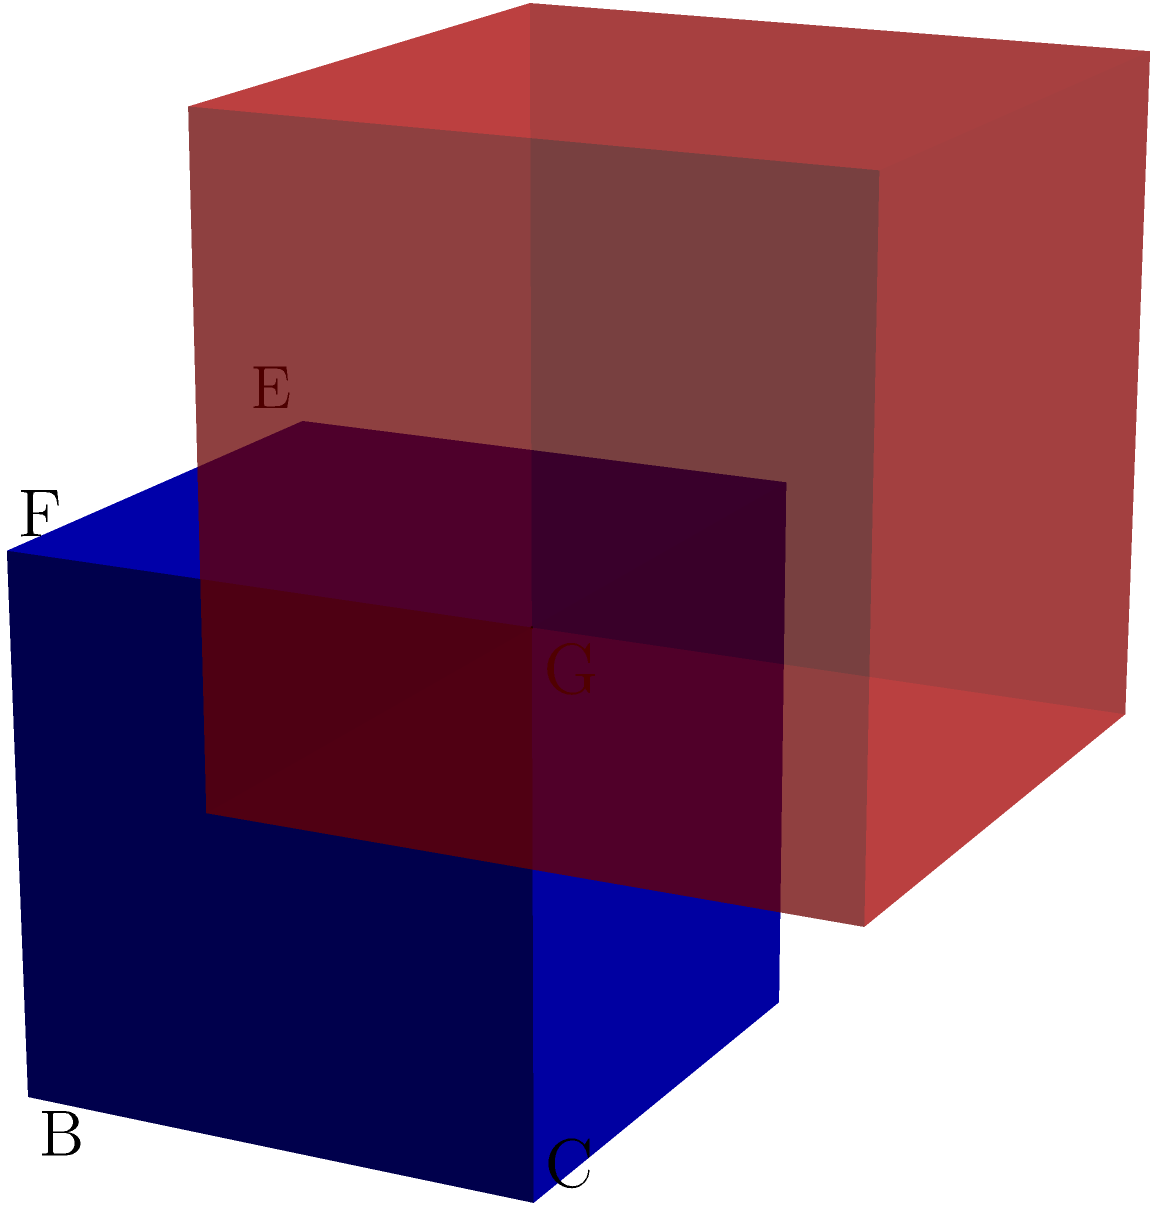In a self-defense scenario, you need to quickly assess and adapt your stance. The blue cube represents your initial position, and the red cube represents the optimal defensive stance. Which single 90-degree rotation around an edge of the blue cube will align it with the red cube, maximizing your personal safety? To solve this spatial problem, let's approach it step-by-step:

1. Observe the initial (blue) and target (red) positions of the cube.

2. Notice that the vertex A of the blue cube needs to move to the position of vertex G in the red cube.

3. Identify possible rotation axes:
   - Edge AB
   - Edge AD
   - Edge AE

4. Analyze each rotation:
   - Rotation around AB would move A to D, which is not correct.
   - Rotation around AD would move A to E, which is not correct.
   - Rotation around AE would move A to G, which is the desired position.

5. Confirm that a 90-degree rotation around edge AE (the vertical edge from A to E) will:
   - Move A to G
   - Move B to F
   - Move D to H
   - Move E to C

6. This rotation aligns all vertices of the blue cube with the corresponding vertices of the red cube.

Therefore, a single 90-degree rotation around the vertical edge AE (from the front bottom left corner to the front top left corner) will transform the blue cube into the position of the red cube, representing the optimal defensive stance.
Answer: 90-degree rotation around edge AE 